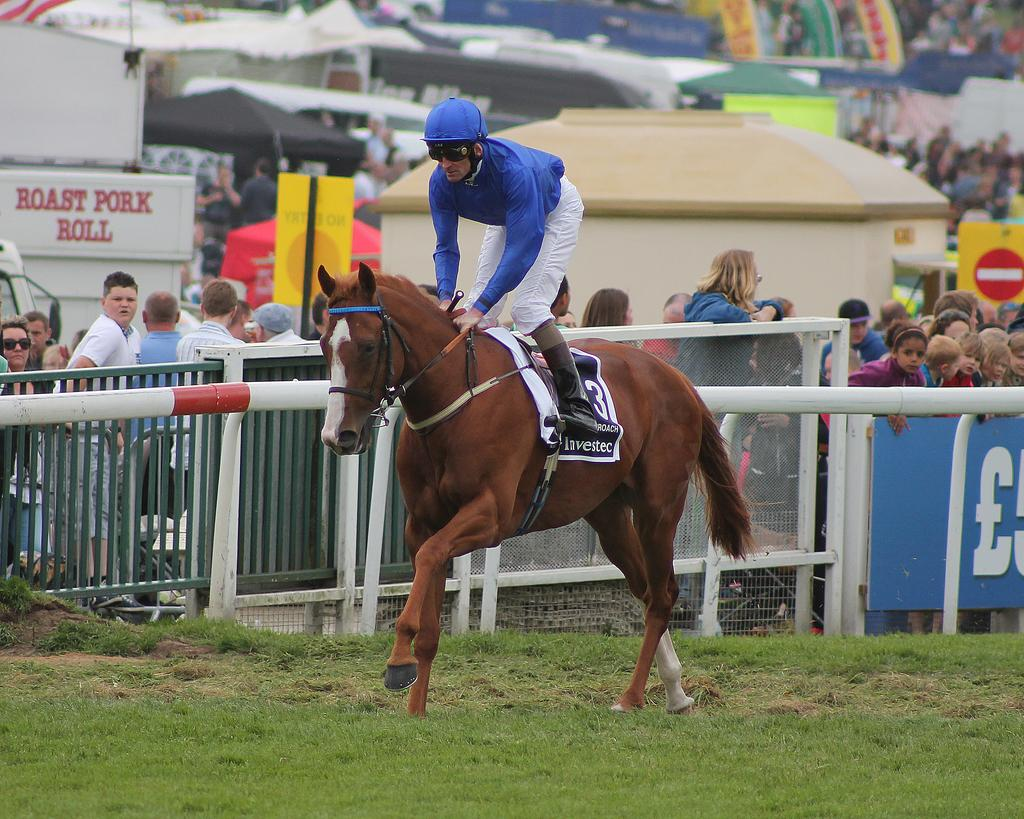What is the main subject in the middle of the image? There is a horse in the middle of the image. Who is on the horse? A man is on the horse. What is the man wearing? The man is wearing a blue shirt, trousers, and a helmet. What can be seen in the background of the image? There are many people, a fence, tents, and grass in the background of the image. What type of toothbrush is the man using while riding the horse in the image? There is no toothbrush present in the image, and the man is not using one while riding the horse. 